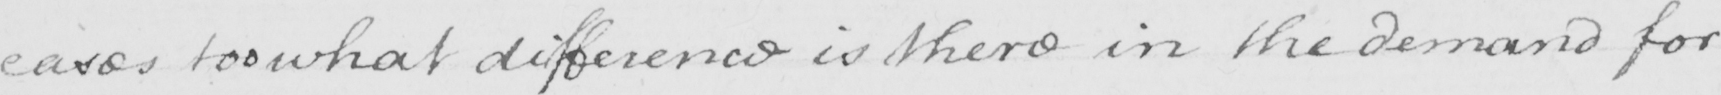What text is written in this handwritten line? cases too what difference is there in the demand for 